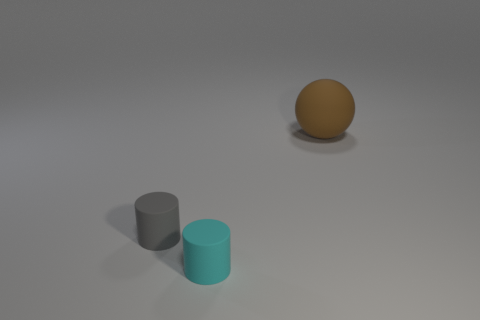Can you tell me what shapes are present in the image and their colors? Certainly! In the image, there are three distinct shapes. Starting from the left, there's a matte gray cylinder, then a slightly reflective cyan cylinder, and on the far right, a matte brown sphere. Each shape has a different color and finish, contributing to the simplicity and contrast within the scene. 